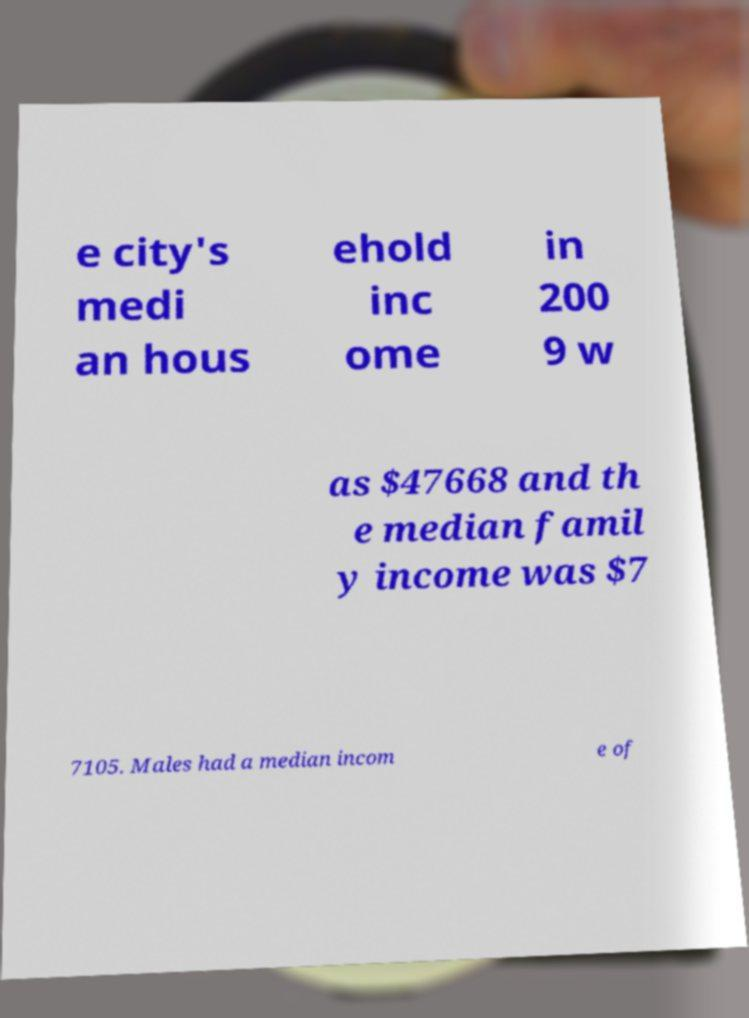Can you accurately transcribe the text from the provided image for me? e city's medi an hous ehold inc ome in 200 9 w as $47668 and th e median famil y income was $7 7105. Males had a median incom e of 